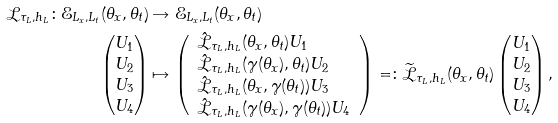Convert formula to latex. <formula><loc_0><loc_0><loc_500><loc_500>\mathcal { L } _ { \tau _ { L } , h _ { L } } \colon \mathcal { E } _ { L _ { x } , L _ { t } } ( \theta _ { x } , \theta _ { t } ) & \rightarrow \mathcal { E } _ { L _ { x } , L _ { t } } ( \theta _ { x } , \theta _ { t } ) \\ \begin{pmatrix} U _ { 1 } \\ U _ { 2 } \\ U _ { 3 } \\ U _ { 4 } \end{pmatrix} & \mapsto \left ( \begin{array} { l } \hat { \mathcal { L } } _ { \tau _ { L } , h _ { L } } ( \theta _ { x } , \theta _ { t } ) U _ { 1 } \\ \hat { \mathcal { L } } _ { \tau _ { L } , h _ { L } } ( \gamma ( \theta _ { x } ) , \theta _ { t } ) U _ { 2 } \\ \hat { \mathcal { L } } _ { \tau _ { L } , h _ { L } } ( \theta _ { x } , \gamma ( \theta _ { t } ) ) U _ { 3 } \\ \hat { \mathcal { L } } _ { \tau _ { L } , h _ { L } } ( \gamma ( \theta _ { x } ) , \gamma ( \theta _ { t } ) ) U _ { 4 } \end{array} \right ) = \colon \widetilde { \mathcal { L } } _ { \tau _ { L } , h _ { L } } ( \theta _ { x } , \theta _ { t } ) \begin{pmatrix} U _ { 1 } \\ U _ { 2 } \\ U _ { 3 } \\ U _ { 4 } \end{pmatrix} ,</formula> 